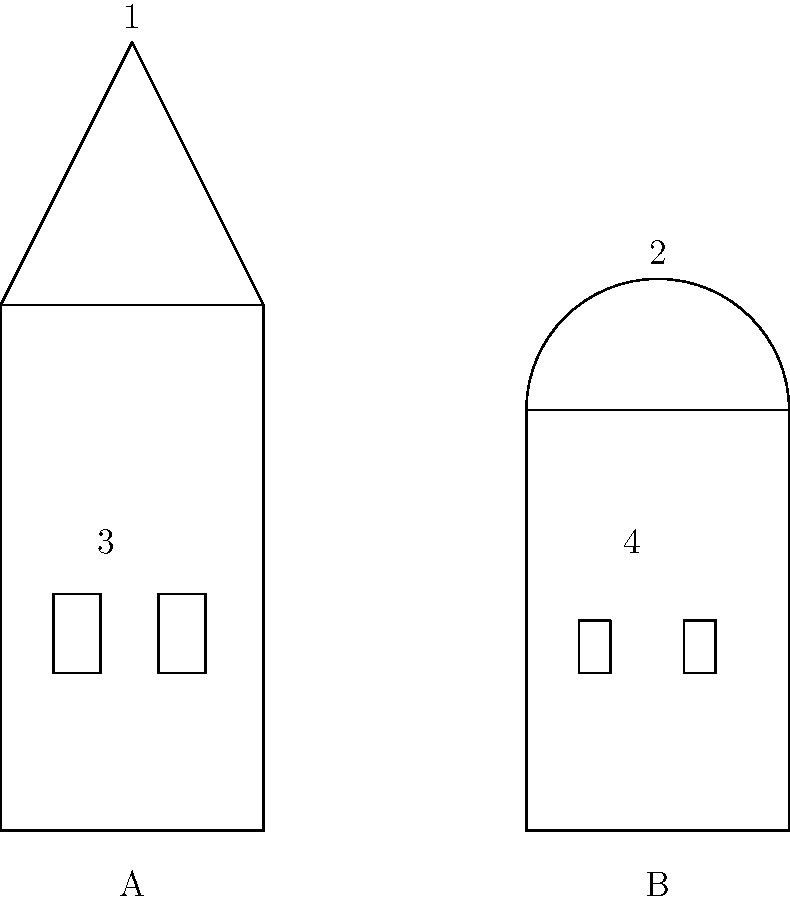Compare the architectural styles of the two historical Ukrainian buildings shown in the annotated diagram. Identify the styles represented by A and B, and explain the significance of the labeled features (1-4) in distinguishing these styles. To answer this question, we need to analyze the key features of each building:

1. Building A:
   - Rectangular base structure
   - Triangular roof (labeled 1)
   - Rectangular windows (labeled 3)

These features are characteristic of the Baroque style, which was prevalent in Ukraine during the 17th and 18th centuries.

2. Building B:
   - Rectangular base structure
   - Domed roof (labeled 2)
   - Arched windows (labeled 4)

These features are typical of the Byzantine style, which influenced Ukrainian architecture from the 10th to the 13th centuries.

Significance of labeled features:

1. Triangular roof (Baroque): Represents the ornate and dramatic style of Baroque architecture, often featuring steep, pitched roofs.

2. Domed roof (Byzantine): A hallmark of Byzantine architecture, symbolizing the heavens and often used in religious buildings.

3. Rectangular windows (Baroque): Reflect the emphasis on symmetry and grandeur in Baroque design, often adorned with elaborate frames.

4. Arched windows (Byzantine): Characteristic of Byzantine architecture, providing both structural support and aesthetic appeal.

The comparison of these styles highlights the diverse architectural influences in Ukrainian history, from the early medieval Byzantine period to the later Baroque era, reflecting the country's rich cultural heritage and geopolitical position between East and West.
Answer: A: Baroque, B: Byzantine. 1: Triangular roof (Baroque), 2: Domed roof (Byzantine), 3: Rectangular windows (Baroque), 4: Arched windows (Byzantine). 